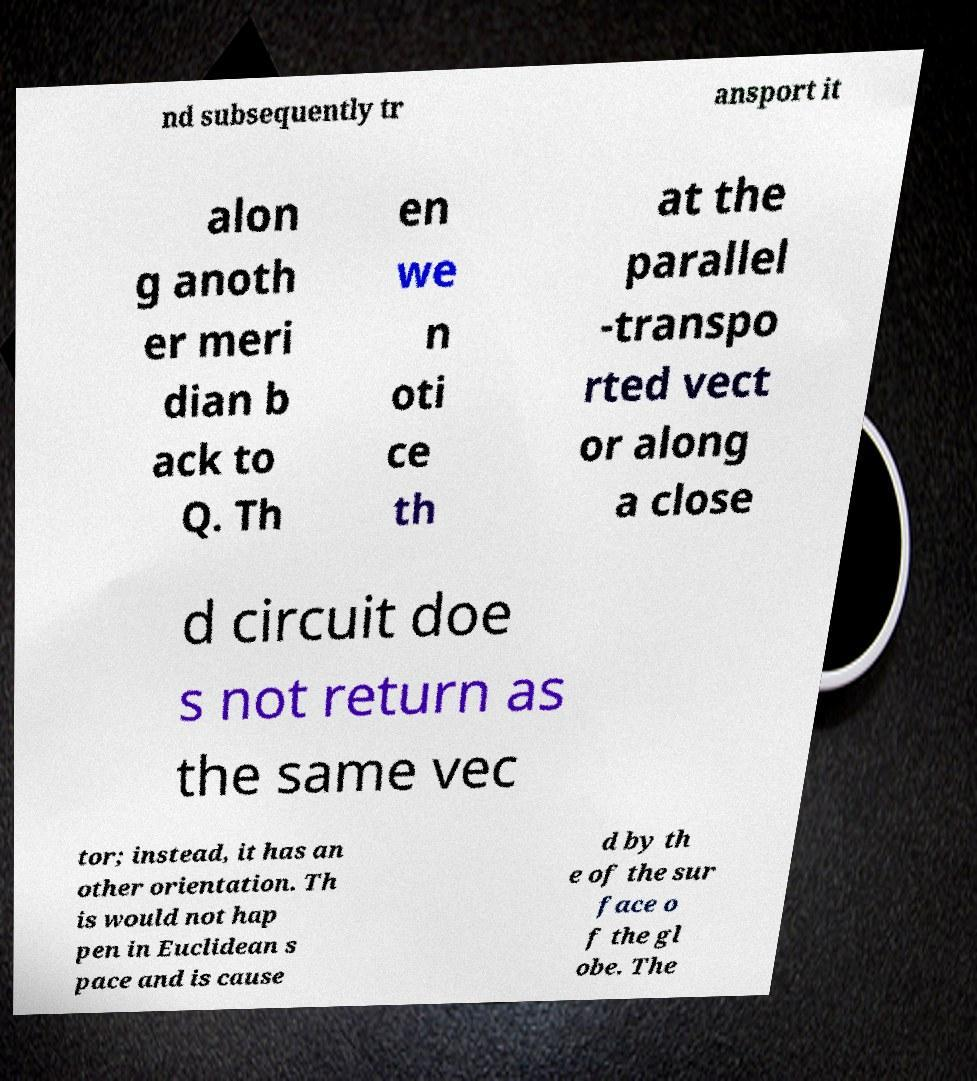Please identify and transcribe the text found in this image. nd subsequently tr ansport it alon g anoth er meri dian b ack to Q. Th en we n oti ce th at the parallel -transpo rted vect or along a close d circuit doe s not return as the same vec tor; instead, it has an other orientation. Th is would not hap pen in Euclidean s pace and is cause d by th e of the sur face o f the gl obe. The 